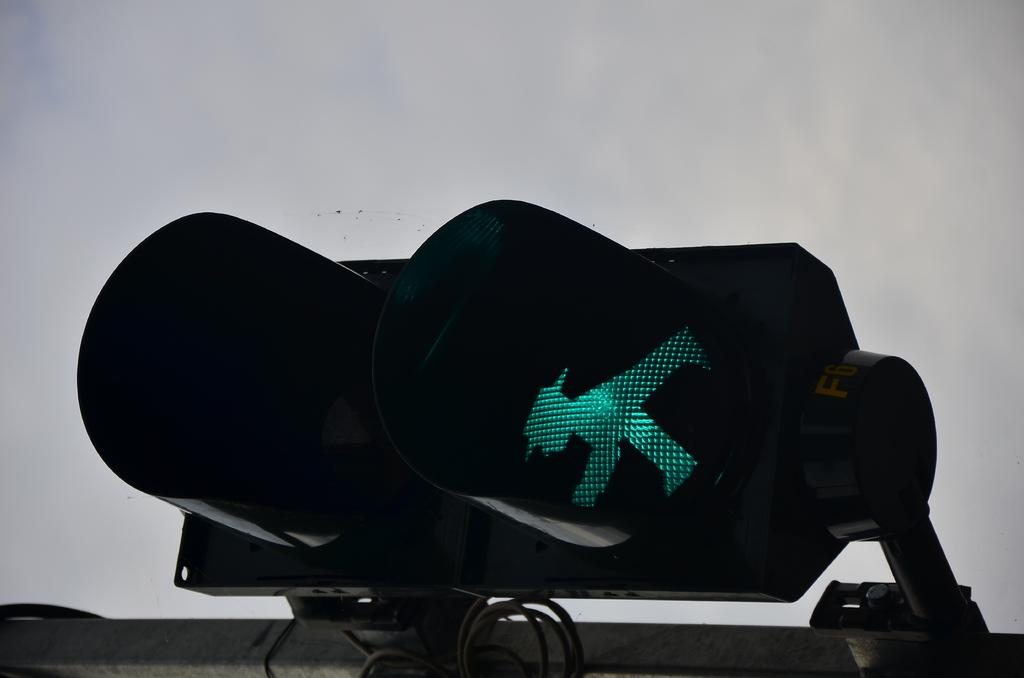What is the main object in the image? There is a traffic signal light in the image. What else can be seen in the image besides the traffic signal light? There are wires and rods in the image. What is visible in the background of the image? The sky is visible in the background of the image. What can be observed in the sky? Clouds are present in the sky. What color is the orange that the hand is holding in the image? There is no orange or hand present in the image; it only features a traffic signal light, wires, rods, and a sky with clouds. 